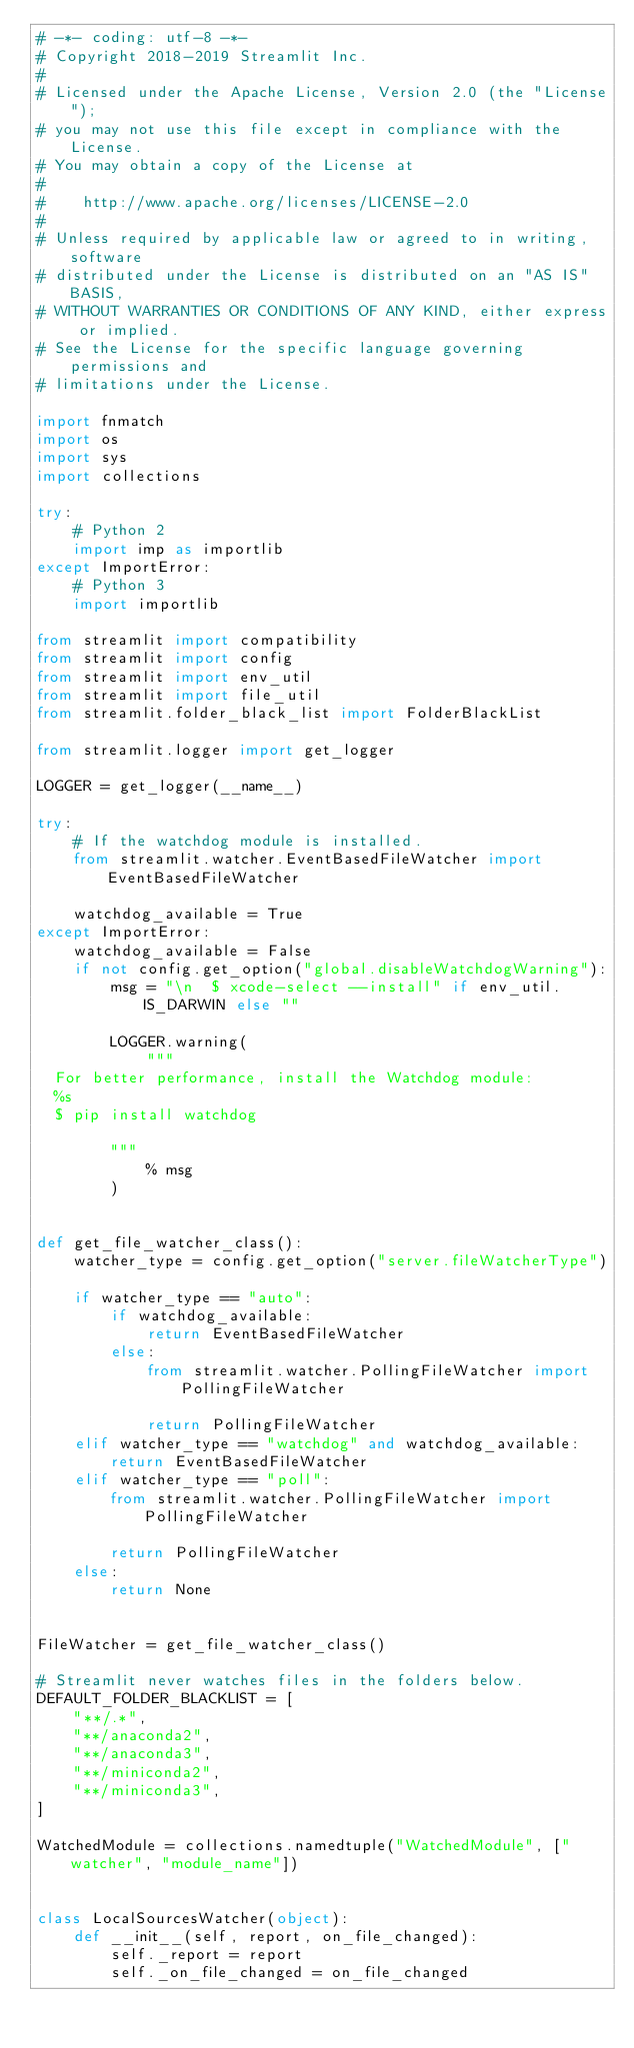Convert code to text. <code><loc_0><loc_0><loc_500><loc_500><_Python_># -*- coding: utf-8 -*-
# Copyright 2018-2019 Streamlit Inc.
#
# Licensed under the Apache License, Version 2.0 (the "License");
# you may not use this file except in compliance with the License.
# You may obtain a copy of the License at
#
#    http://www.apache.org/licenses/LICENSE-2.0
#
# Unless required by applicable law or agreed to in writing, software
# distributed under the License is distributed on an "AS IS" BASIS,
# WITHOUT WARRANTIES OR CONDITIONS OF ANY KIND, either express or implied.
# See the License for the specific language governing permissions and
# limitations under the License.

import fnmatch
import os
import sys
import collections

try:
    # Python 2
    import imp as importlib
except ImportError:
    # Python 3
    import importlib

from streamlit import compatibility
from streamlit import config
from streamlit import env_util
from streamlit import file_util
from streamlit.folder_black_list import FolderBlackList

from streamlit.logger import get_logger

LOGGER = get_logger(__name__)

try:
    # If the watchdog module is installed.
    from streamlit.watcher.EventBasedFileWatcher import EventBasedFileWatcher

    watchdog_available = True
except ImportError:
    watchdog_available = False
    if not config.get_option("global.disableWatchdogWarning"):
        msg = "\n  $ xcode-select --install" if env_util.IS_DARWIN else ""

        LOGGER.warning(
            """
  For better performance, install the Watchdog module:
  %s
  $ pip install watchdog

        """
            % msg
        )


def get_file_watcher_class():
    watcher_type = config.get_option("server.fileWatcherType")

    if watcher_type == "auto":
        if watchdog_available:
            return EventBasedFileWatcher
        else:
            from streamlit.watcher.PollingFileWatcher import PollingFileWatcher

            return PollingFileWatcher
    elif watcher_type == "watchdog" and watchdog_available:
        return EventBasedFileWatcher
    elif watcher_type == "poll":
        from streamlit.watcher.PollingFileWatcher import PollingFileWatcher

        return PollingFileWatcher
    else:
        return None


FileWatcher = get_file_watcher_class()

# Streamlit never watches files in the folders below.
DEFAULT_FOLDER_BLACKLIST = [
    "**/.*",
    "**/anaconda2",
    "**/anaconda3",
    "**/miniconda2",
    "**/miniconda3",
]

WatchedModule = collections.namedtuple("WatchedModule", ["watcher", "module_name"])


class LocalSourcesWatcher(object):
    def __init__(self, report, on_file_changed):
        self._report = report
        self._on_file_changed = on_file_changed</code> 